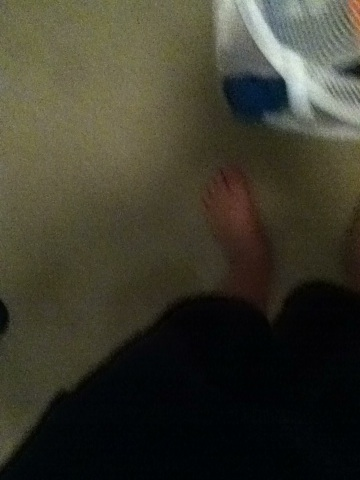Create a long, detailed, and realistic scenario that could be taking place in this image. It's a quiet Saturday morning, and a young adult is at home enjoying a leisurely start to the weekend. Having just rolled out of bed, they walk over to the corner of their bedroom where a white laundry basket sits. The basket, filled with a week's worth of clothes, hints at the busy days they've had – the blues and whites of office attire mixed with the casual wears of evenings and weekends. They stand barefoot, feeling the soft texture of the carpet under their feet, contemplating the task ahead. With a sigh, they begin sorting the clothes, separating colors from whites. They think about the plans for the day, perhaps a visit to the grocery store and catching up with friends later. The mundane task of laundry grounds them, providing a gentle start to what they hope will be a relaxing day. 